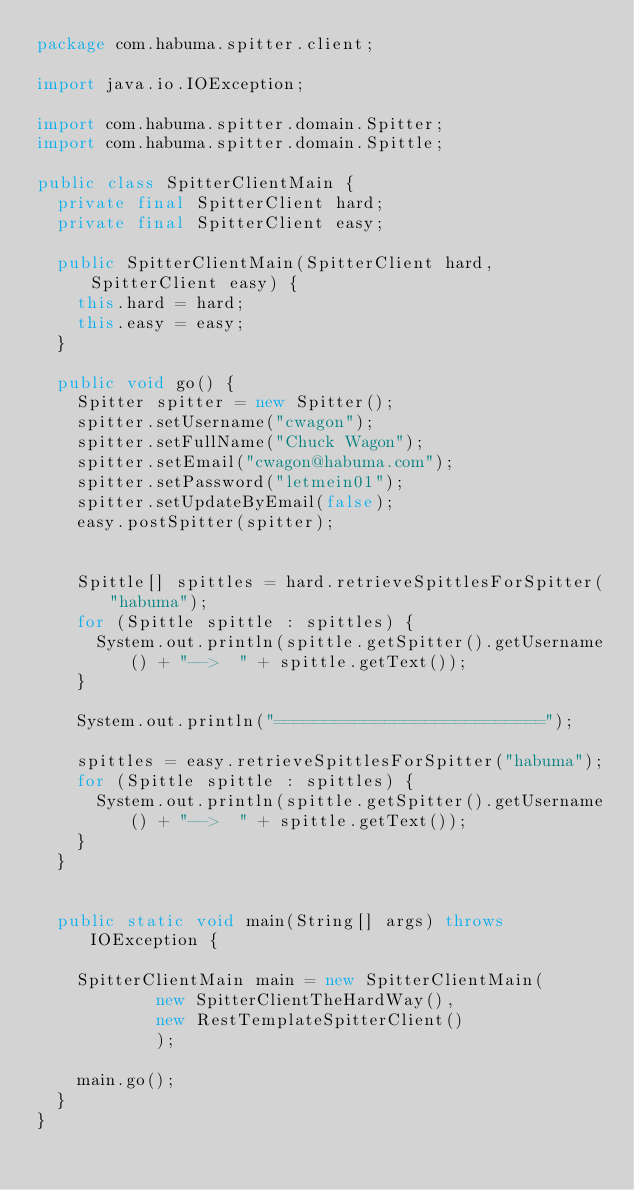Convert code to text. <code><loc_0><loc_0><loc_500><loc_500><_Java_>package com.habuma.spitter.client;

import java.io.IOException;

import com.habuma.spitter.domain.Spitter;
import com.habuma.spitter.domain.Spittle;

public class SpitterClientMain {
  private final SpitterClient hard;
  private final SpitterClient easy;
  
  public SpitterClientMain(SpitterClient hard, SpitterClient easy) {
    this.hard = hard;
    this.easy = easy;
  }
  
  public void go() {
    Spitter spitter = new Spitter();
    spitter.setUsername("cwagon");
    spitter.setFullName("Chuck Wagon");
    spitter.setEmail("cwagon@habuma.com");
    spitter.setPassword("letmein01");
    spitter.setUpdateByEmail(false);
    easy.postSpitter(spitter);
    
    
    Spittle[] spittles = hard.retrieveSpittlesForSpitter("habuma");
    for (Spittle spittle : spittles) {
      System.out.println(spittle.getSpitter().getUsername() + "-->  " + spittle.getText());
    }
    
    System.out.println("===========================");
    
    spittles = easy.retrieveSpittlesForSpitter("habuma");
    for (Spittle spittle : spittles) {
      System.out.println(spittle.getSpitter().getUsername() + "-->  " + spittle.getText());
    }      
  }
  
  
  public static void main(String[] args) throws IOException {
    
    SpitterClientMain main = new SpitterClientMain(
            new SpitterClientTheHardWay(),
            new RestTemplateSpitterClient()
            );
    
    main.go();
  }
}
</code> 